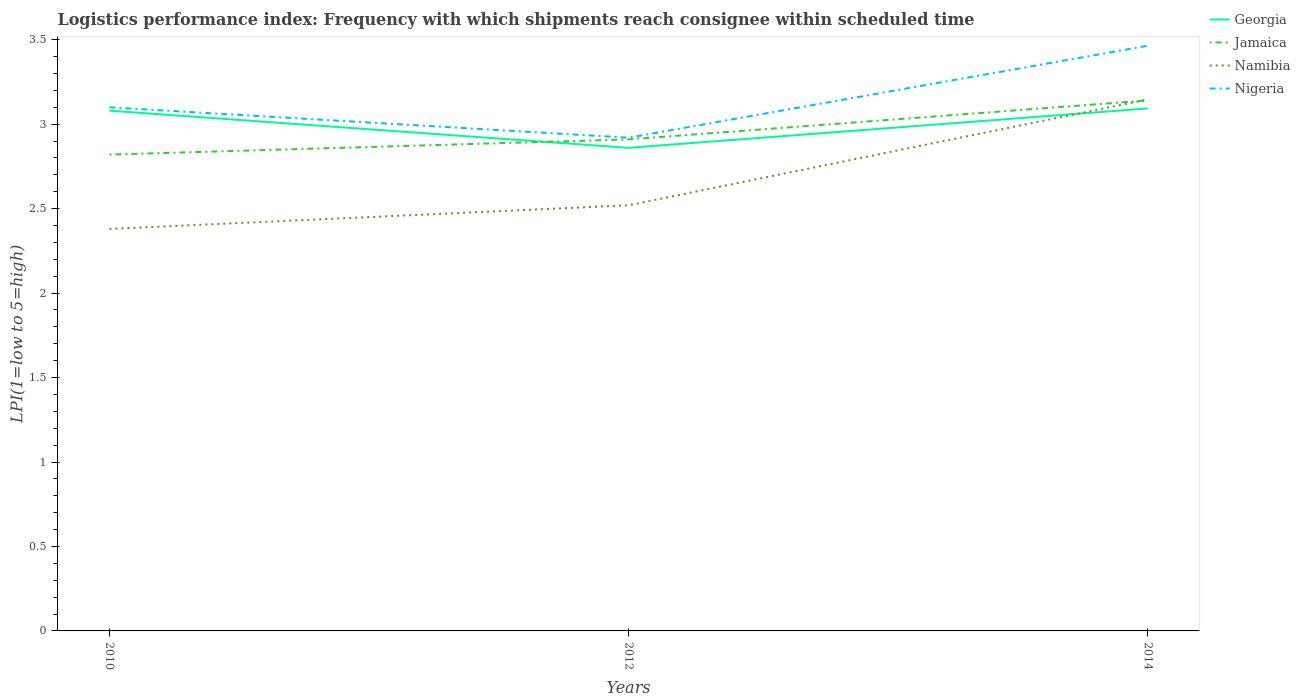Is the number of lines equal to the number of legend labels?
Your answer should be very brief. Yes. Across all years, what is the maximum logistics performance index in Georgia?
Your answer should be very brief. 2.86. In which year was the logistics performance index in Georgia maximum?
Ensure brevity in your answer.  2012. What is the total logistics performance index in Namibia in the graph?
Ensure brevity in your answer.  -0.63. What is the difference between the highest and the second highest logistics performance index in Georgia?
Offer a very short reply. 0.23. How many years are there in the graph?
Ensure brevity in your answer.  3. Does the graph contain any zero values?
Provide a succinct answer. No. Does the graph contain grids?
Ensure brevity in your answer.  No. How many legend labels are there?
Provide a succinct answer. 4. What is the title of the graph?
Keep it short and to the point. Logistics performance index: Frequency with which shipments reach consignee within scheduled time. What is the label or title of the X-axis?
Give a very brief answer. Years. What is the label or title of the Y-axis?
Your answer should be compact. LPI(1=low to 5=high). What is the LPI(1=low to 5=high) in Georgia in 2010?
Your answer should be compact. 3.08. What is the LPI(1=low to 5=high) in Jamaica in 2010?
Offer a terse response. 2.82. What is the LPI(1=low to 5=high) in Namibia in 2010?
Keep it short and to the point. 2.38. What is the LPI(1=low to 5=high) in Nigeria in 2010?
Make the answer very short. 3.1. What is the LPI(1=low to 5=high) in Georgia in 2012?
Your response must be concise. 2.86. What is the LPI(1=low to 5=high) of Jamaica in 2012?
Provide a short and direct response. 2.91. What is the LPI(1=low to 5=high) in Namibia in 2012?
Ensure brevity in your answer.  2.52. What is the LPI(1=low to 5=high) of Nigeria in 2012?
Make the answer very short. 2.92. What is the LPI(1=low to 5=high) in Georgia in 2014?
Offer a very short reply. 3.09. What is the LPI(1=low to 5=high) of Jamaica in 2014?
Provide a short and direct response. 3.14. What is the LPI(1=low to 5=high) of Namibia in 2014?
Keep it short and to the point. 3.15. What is the LPI(1=low to 5=high) in Nigeria in 2014?
Your response must be concise. 3.46. Across all years, what is the maximum LPI(1=low to 5=high) in Georgia?
Your answer should be very brief. 3.09. Across all years, what is the maximum LPI(1=low to 5=high) in Jamaica?
Make the answer very short. 3.14. Across all years, what is the maximum LPI(1=low to 5=high) in Namibia?
Your answer should be very brief. 3.15. Across all years, what is the maximum LPI(1=low to 5=high) of Nigeria?
Provide a short and direct response. 3.46. Across all years, what is the minimum LPI(1=low to 5=high) in Georgia?
Offer a very short reply. 2.86. Across all years, what is the minimum LPI(1=low to 5=high) in Jamaica?
Offer a terse response. 2.82. Across all years, what is the minimum LPI(1=low to 5=high) in Namibia?
Keep it short and to the point. 2.38. Across all years, what is the minimum LPI(1=low to 5=high) in Nigeria?
Provide a short and direct response. 2.92. What is the total LPI(1=low to 5=high) of Georgia in the graph?
Ensure brevity in your answer.  9.03. What is the total LPI(1=low to 5=high) in Jamaica in the graph?
Your response must be concise. 8.87. What is the total LPI(1=low to 5=high) in Namibia in the graph?
Keep it short and to the point. 8.05. What is the total LPI(1=low to 5=high) in Nigeria in the graph?
Ensure brevity in your answer.  9.48. What is the difference between the LPI(1=low to 5=high) in Georgia in 2010 and that in 2012?
Give a very brief answer. 0.22. What is the difference between the LPI(1=low to 5=high) of Jamaica in 2010 and that in 2012?
Offer a very short reply. -0.09. What is the difference between the LPI(1=low to 5=high) in Namibia in 2010 and that in 2012?
Provide a short and direct response. -0.14. What is the difference between the LPI(1=low to 5=high) in Nigeria in 2010 and that in 2012?
Your answer should be very brief. 0.18. What is the difference between the LPI(1=low to 5=high) of Georgia in 2010 and that in 2014?
Offer a very short reply. -0.01. What is the difference between the LPI(1=low to 5=high) of Jamaica in 2010 and that in 2014?
Your response must be concise. -0.32. What is the difference between the LPI(1=low to 5=high) in Namibia in 2010 and that in 2014?
Provide a short and direct response. -0.77. What is the difference between the LPI(1=low to 5=high) in Nigeria in 2010 and that in 2014?
Offer a terse response. -0.36. What is the difference between the LPI(1=low to 5=high) of Georgia in 2012 and that in 2014?
Provide a succinct answer. -0.23. What is the difference between the LPI(1=low to 5=high) in Jamaica in 2012 and that in 2014?
Your answer should be very brief. -0.23. What is the difference between the LPI(1=low to 5=high) of Namibia in 2012 and that in 2014?
Provide a short and direct response. -0.63. What is the difference between the LPI(1=low to 5=high) in Nigeria in 2012 and that in 2014?
Provide a succinct answer. -0.54. What is the difference between the LPI(1=low to 5=high) of Georgia in 2010 and the LPI(1=low to 5=high) of Jamaica in 2012?
Your answer should be very brief. 0.17. What is the difference between the LPI(1=low to 5=high) of Georgia in 2010 and the LPI(1=low to 5=high) of Namibia in 2012?
Provide a short and direct response. 0.56. What is the difference between the LPI(1=low to 5=high) in Georgia in 2010 and the LPI(1=low to 5=high) in Nigeria in 2012?
Make the answer very short. 0.16. What is the difference between the LPI(1=low to 5=high) in Jamaica in 2010 and the LPI(1=low to 5=high) in Namibia in 2012?
Offer a terse response. 0.3. What is the difference between the LPI(1=low to 5=high) in Jamaica in 2010 and the LPI(1=low to 5=high) in Nigeria in 2012?
Make the answer very short. -0.1. What is the difference between the LPI(1=low to 5=high) in Namibia in 2010 and the LPI(1=low to 5=high) in Nigeria in 2012?
Offer a very short reply. -0.54. What is the difference between the LPI(1=low to 5=high) in Georgia in 2010 and the LPI(1=low to 5=high) in Jamaica in 2014?
Make the answer very short. -0.06. What is the difference between the LPI(1=low to 5=high) in Georgia in 2010 and the LPI(1=low to 5=high) in Namibia in 2014?
Keep it short and to the point. -0.07. What is the difference between the LPI(1=low to 5=high) in Georgia in 2010 and the LPI(1=low to 5=high) in Nigeria in 2014?
Provide a succinct answer. -0.38. What is the difference between the LPI(1=low to 5=high) in Jamaica in 2010 and the LPI(1=low to 5=high) in Namibia in 2014?
Offer a terse response. -0.33. What is the difference between the LPI(1=low to 5=high) in Jamaica in 2010 and the LPI(1=low to 5=high) in Nigeria in 2014?
Your response must be concise. -0.64. What is the difference between the LPI(1=low to 5=high) of Namibia in 2010 and the LPI(1=low to 5=high) of Nigeria in 2014?
Offer a very short reply. -1.08. What is the difference between the LPI(1=low to 5=high) in Georgia in 2012 and the LPI(1=low to 5=high) in Jamaica in 2014?
Keep it short and to the point. -0.28. What is the difference between the LPI(1=low to 5=high) in Georgia in 2012 and the LPI(1=low to 5=high) in Namibia in 2014?
Ensure brevity in your answer.  -0.29. What is the difference between the LPI(1=low to 5=high) in Georgia in 2012 and the LPI(1=low to 5=high) in Nigeria in 2014?
Your response must be concise. -0.6. What is the difference between the LPI(1=low to 5=high) of Jamaica in 2012 and the LPI(1=low to 5=high) of Namibia in 2014?
Provide a succinct answer. -0.24. What is the difference between the LPI(1=low to 5=high) in Jamaica in 2012 and the LPI(1=low to 5=high) in Nigeria in 2014?
Give a very brief answer. -0.55. What is the difference between the LPI(1=low to 5=high) in Namibia in 2012 and the LPI(1=low to 5=high) in Nigeria in 2014?
Provide a succinct answer. -0.94. What is the average LPI(1=low to 5=high) in Georgia per year?
Offer a terse response. 3.01. What is the average LPI(1=low to 5=high) of Jamaica per year?
Provide a succinct answer. 2.96. What is the average LPI(1=low to 5=high) of Namibia per year?
Your answer should be very brief. 2.68. What is the average LPI(1=low to 5=high) of Nigeria per year?
Provide a short and direct response. 3.16. In the year 2010, what is the difference between the LPI(1=low to 5=high) of Georgia and LPI(1=low to 5=high) of Jamaica?
Offer a terse response. 0.26. In the year 2010, what is the difference between the LPI(1=low to 5=high) of Georgia and LPI(1=low to 5=high) of Namibia?
Your answer should be compact. 0.7. In the year 2010, what is the difference between the LPI(1=low to 5=high) in Georgia and LPI(1=low to 5=high) in Nigeria?
Your response must be concise. -0.02. In the year 2010, what is the difference between the LPI(1=low to 5=high) of Jamaica and LPI(1=low to 5=high) of Namibia?
Ensure brevity in your answer.  0.44. In the year 2010, what is the difference between the LPI(1=low to 5=high) in Jamaica and LPI(1=low to 5=high) in Nigeria?
Give a very brief answer. -0.28. In the year 2010, what is the difference between the LPI(1=low to 5=high) in Namibia and LPI(1=low to 5=high) in Nigeria?
Make the answer very short. -0.72. In the year 2012, what is the difference between the LPI(1=low to 5=high) in Georgia and LPI(1=low to 5=high) in Namibia?
Make the answer very short. 0.34. In the year 2012, what is the difference between the LPI(1=low to 5=high) in Georgia and LPI(1=low to 5=high) in Nigeria?
Your response must be concise. -0.06. In the year 2012, what is the difference between the LPI(1=low to 5=high) of Jamaica and LPI(1=low to 5=high) of Namibia?
Make the answer very short. 0.39. In the year 2012, what is the difference between the LPI(1=low to 5=high) in Jamaica and LPI(1=low to 5=high) in Nigeria?
Offer a very short reply. -0.01. In the year 2014, what is the difference between the LPI(1=low to 5=high) of Georgia and LPI(1=low to 5=high) of Jamaica?
Give a very brief answer. -0.05. In the year 2014, what is the difference between the LPI(1=low to 5=high) of Georgia and LPI(1=low to 5=high) of Namibia?
Make the answer very short. -0.05. In the year 2014, what is the difference between the LPI(1=low to 5=high) of Georgia and LPI(1=low to 5=high) of Nigeria?
Ensure brevity in your answer.  -0.37. In the year 2014, what is the difference between the LPI(1=low to 5=high) of Jamaica and LPI(1=low to 5=high) of Namibia?
Give a very brief answer. -0.01. In the year 2014, what is the difference between the LPI(1=low to 5=high) of Jamaica and LPI(1=low to 5=high) of Nigeria?
Your answer should be very brief. -0.32. In the year 2014, what is the difference between the LPI(1=low to 5=high) of Namibia and LPI(1=low to 5=high) of Nigeria?
Ensure brevity in your answer.  -0.32. What is the ratio of the LPI(1=low to 5=high) of Georgia in 2010 to that in 2012?
Your response must be concise. 1.08. What is the ratio of the LPI(1=low to 5=high) of Jamaica in 2010 to that in 2012?
Give a very brief answer. 0.97. What is the ratio of the LPI(1=low to 5=high) of Nigeria in 2010 to that in 2012?
Your answer should be compact. 1.06. What is the ratio of the LPI(1=low to 5=high) of Jamaica in 2010 to that in 2014?
Provide a succinct answer. 0.9. What is the ratio of the LPI(1=low to 5=high) in Namibia in 2010 to that in 2014?
Your response must be concise. 0.76. What is the ratio of the LPI(1=low to 5=high) of Nigeria in 2010 to that in 2014?
Your answer should be compact. 0.89. What is the ratio of the LPI(1=low to 5=high) of Georgia in 2012 to that in 2014?
Offer a terse response. 0.92. What is the ratio of the LPI(1=low to 5=high) in Jamaica in 2012 to that in 2014?
Offer a terse response. 0.93. What is the ratio of the LPI(1=low to 5=high) in Namibia in 2012 to that in 2014?
Provide a succinct answer. 0.8. What is the ratio of the LPI(1=low to 5=high) of Nigeria in 2012 to that in 2014?
Offer a very short reply. 0.84. What is the difference between the highest and the second highest LPI(1=low to 5=high) of Georgia?
Offer a terse response. 0.01. What is the difference between the highest and the second highest LPI(1=low to 5=high) in Jamaica?
Your answer should be very brief. 0.23. What is the difference between the highest and the second highest LPI(1=low to 5=high) in Namibia?
Give a very brief answer. 0.63. What is the difference between the highest and the second highest LPI(1=low to 5=high) of Nigeria?
Ensure brevity in your answer.  0.36. What is the difference between the highest and the lowest LPI(1=low to 5=high) in Georgia?
Your answer should be very brief. 0.23. What is the difference between the highest and the lowest LPI(1=low to 5=high) of Jamaica?
Provide a short and direct response. 0.32. What is the difference between the highest and the lowest LPI(1=low to 5=high) in Namibia?
Provide a succinct answer. 0.77. What is the difference between the highest and the lowest LPI(1=low to 5=high) in Nigeria?
Offer a terse response. 0.54. 